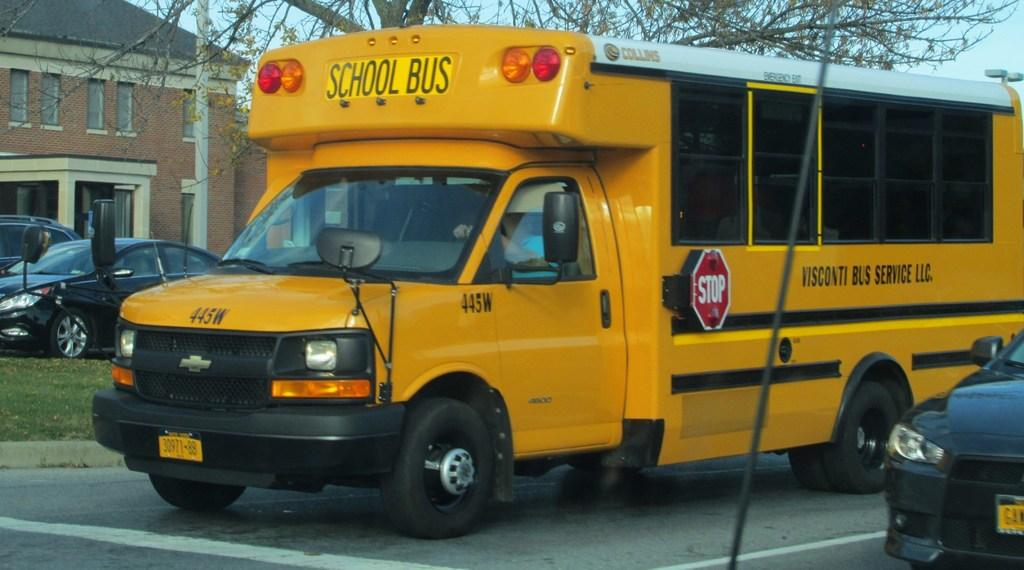<image>
Present a compact description of the photo's key features. A yellow school bus, with the word school bus written on it. 